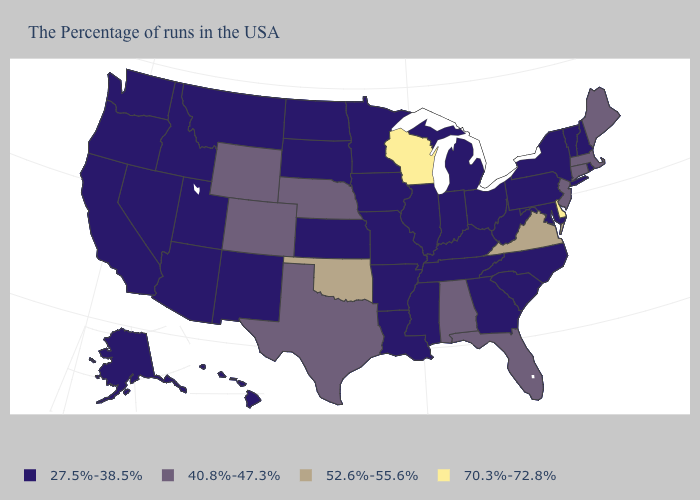Does the first symbol in the legend represent the smallest category?
Give a very brief answer. Yes. What is the value of Arkansas?
Quick response, please. 27.5%-38.5%. What is the lowest value in the MidWest?
Write a very short answer. 27.5%-38.5%. Name the states that have a value in the range 27.5%-38.5%?
Be succinct. Rhode Island, New Hampshire, Vermont, New York, Maryland, Pennsylvania, North Carolina, South Carolina, West Virginia, Ohio, Georgia, Michigan, Kentucky, Indiana, Tennessee, Illinois, Mississippi, Louisiana, Missouri, Arkansas, Minnesota, Iowa, Kansas, South Dakota, North Dakota, New Mexico, Utah, Montana, Arizona, Idaho, Nevada, California, Washington, Oregon, Alaska, Hawaii. Among the states that border Delaware , which have the lowest value?
Be succinct. Maryland, Pennsylvania. Name the states that have a value in the range 52.6%-55.6%?
Concise answer only. Virginia, Oklahoma. Does the map have missing data?
Write a very short answer. No. Among the states that border Oklahoma , does Texas have the highest value?
Concise answer only. Yes. What is the value of Idaho?
Quick response, please. 27.5%-38.5%. Name the states that have a value in the range 27.5%-38.5%?
Write a very short answer. Rhode Island, New Hampshire, Vermont, New York, Maryland, Pennsylvania, North Carolina, South Carolina, West Virginia, Ohio, Georgia, Michigan, Kentucky, Indiana, Tennessee, Illinois, Mississippi, Louisiana, Missouri, Arkansas, Minnesota, Iowa, Kansas, South Dakota, North Dakota, New Mexico, Utah, Montana, Arizona, Idaho, Nevada, California, Washington, Oregon, Alaska, Hawaii. Does Indiana have the highest value in the MidWest?
Keep it brief. No. Name the states that have a value in the range 40.8%-47.3%?
Short answer required. Maine, Massachusetts, Connecticut, New Jersey, Florida, Alabama, Nebraska, Texas, Wyoming, Colorado. Among the states that border Montana , which have the lowest value?
Short answer required. South Dakota, North Dakota, Idaho. Among the states that border Minnesota , does South Dakota have the highest value?
Write a very short answer. No. 